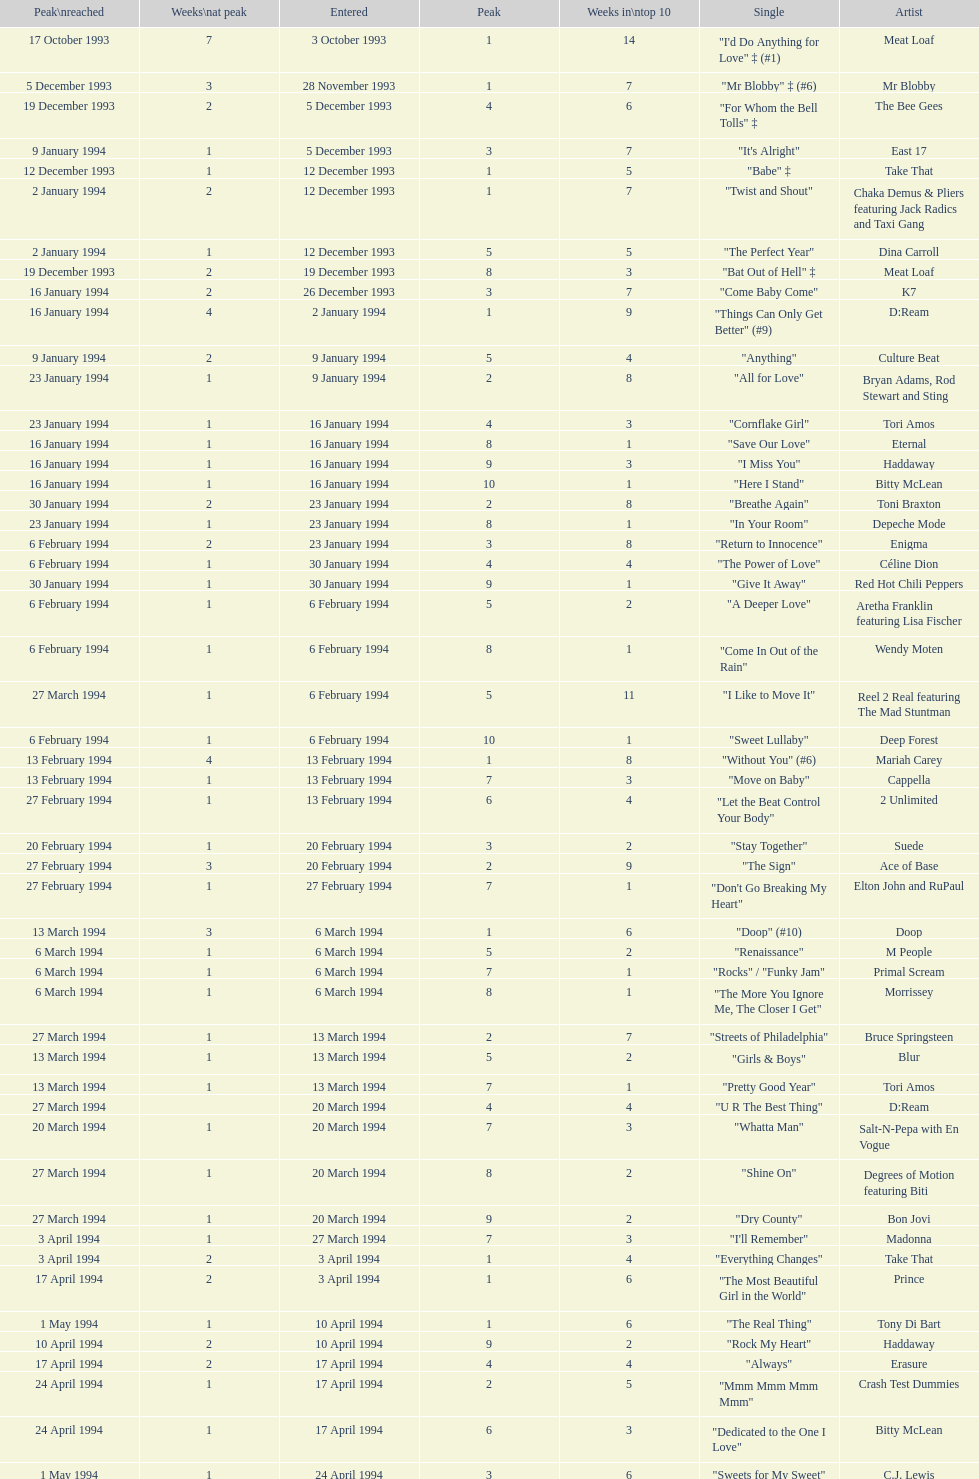Which artist only has its single entered on 2 january 1994? D:Ream. 